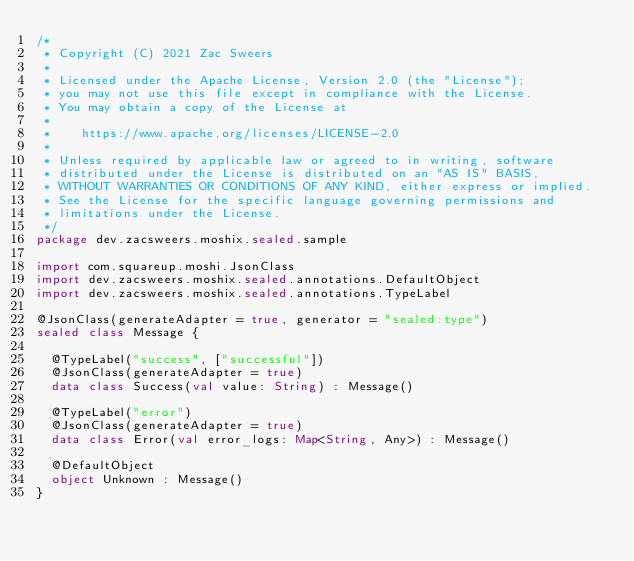Convert code to text. <code><loc_0><loc_0><loc_500><loc_500><_Kotlin_>/*
 * Copyright (C) 2021 Zac Sweers
 *
 * Licensed under the Apache License, Version 2.0 (the "License");
 * you may not use this file except in compliance with the License.
 * You may obtain a copy of the License at
 *
 *    https://www.apache.org/licenses/LICENSE-2.0
 *
 * Unless required by applicable law or agreed to in writing, software
 * distributed under the License is distributed on an "AS IS" BASIS,
 * WITHOUT WARRANTIES OR CONDITIONS OF ANY KIND, either express or implied.
 * See the License for the specific language governing permissions and
 * limitations under the License.
 */
package dev.zacsweers.moshix.sealed.sample

import com.squareup.moshi.JsonClass
import dev.zacsweers.moshix.sealed.annotations.DefaultObject
import dev.zacsweers.moshix.sealed.annotations.TypeLabel

@JsonClass(generateAdapter = true, generator = "sealed:type")
sealed class Message {

  @TypeLabel("success", ["successful"])
  @JsonClass(generateAdapter = true)
  data class Success(val value: String) : Message()

  @TypeLabel("error")
  @JsonClass(generateAdapter = true)
  data class Error(val error_logs: Map<String, Any>) : Message()

  @DefaultObject
  object Unknown : Message()
}
</code> 